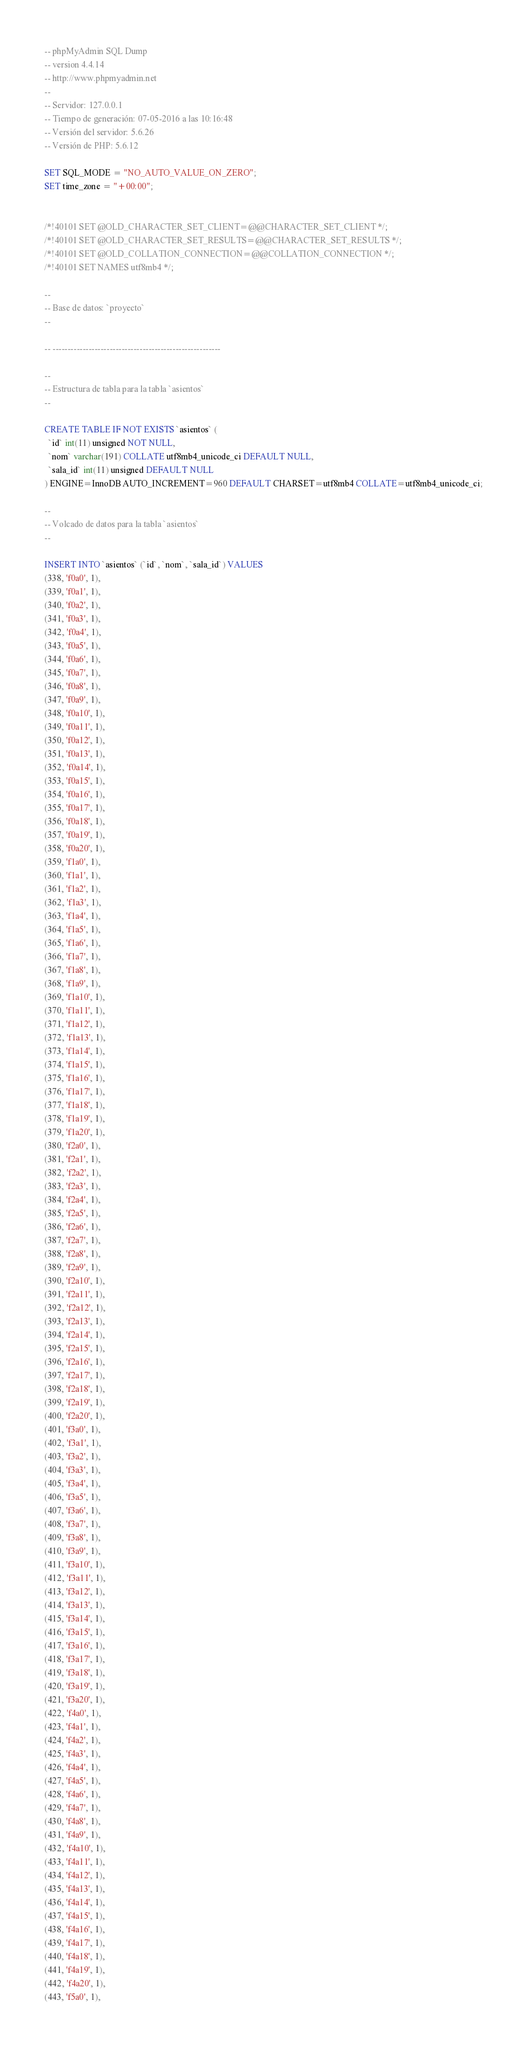Convert code to text. <code><loc_0><loc_0><loc_500><loc_500><_SQL_>-- phpMyAdmin SQL Dump
-- version 4.4.14
-- http://www.phpmyadmin.net
--
-- Servidor: 127.0.0.1
-- Tiempo de generación: 07-05-2016 a las 10:16:48
-- Versión del servidor: 5.6.26
-- Versión de PHP: 5.6.12

SET SQL_MODE = "NO_AUTO_VALUE_ON_ZERO";
SET time_zone = "+00:00";


/*!40101 SET @OLD_CHARACTER_SET_CLIENT=@@CHARACTER_SET_CLIENT */;
/*!40101 SET @OLD_CHARACTER_SET_RESULTS=@@CHARACTER_SET_RESULTS */;
/*!40101 SET @OLD_COLLATION_CONNECTION=@@COLLATION_CONNECTION */;
/*!40101 SET NAMES utf8mb4 */;

--
-- Base de datos: `proyecto`
--

-- --------------------------------------------------------

--
-- Estructura de tabla para la tabla `asientos`
--

CREATE TABLE IF NOT EXISTS `asientos` (
  `id` int(11) unsigned NOT NULL,
  `nom` varchar(191) COLLATE utf8mb4_unicode_ci DEFAULT NULL,
  `sala_id` int(11) unsigned DEFAULT NULL
) ENGINE=InnoDB AUTO_INCREMENT=960 DEFAULT CHARSET=utf8mb4 COLLATE=utf8mb4_unicode_ci;

--
-- Volcado de datos para la tabla `asientos`
--

INSERT INTO `asientos` (`id`, `nom`, `sala_id`) VALUES
(338, 'f0a0', 1),
(339, 'f0a1', 1),
(340, 'f0a2', 1),
(341, 'f0a3', 1),
(342, 'f0a4', 1),
(343, 'f0a5', 1),
(344, 'f0a6', 1),
(345, 'f0a7', 1),
(346, 'f0a8', 1),
(347, 'f0a9', 1),
(348, 'f0a10', 1),
(349, 'f0a11', 1),
(350, 'f0a12', 1),
(351, 'f0a13', 1),
(352, 'f0a14', 1),
(353, 'f0a15', 1),
(354, 'f0a16', 1),
(355, 'f0a17', 1),
(356, 'f0a18', 1),
(357, 'f0a19', 1),
(358, 'f0a20', 1),
(359, 'f1a0', 1),
(360, 'f1a1', 1),
(361, 'f1a2', 1),
(362, 'f1a3', 1),
(363, 'f1a4', 1),
(364, 'f1a5', 1),
(365, 'f1a6', 1),
(366, 'f1a7', 1),
(367, 'f1a8', 1),
(368, 'f1a9', 1),
(369, 'f1a10', 1),
(370, 'f1a11', 1),
(371, 'f1a12', 1),
(372, 'f1a13', 1),
(373, 'f1a14', 1),
(374, 'f1a15', 1),
(375, 'f1a16', 1),
(376, 'f1a17', 1),
(377, 'f1a18', 1),
(378, 'f1a19', 1),
(379, 'f1a20', 1),
(380, 'f2a0', 1),
(381, 'f2a1', 1),
(382, 'f2a2', 1),
(383, 'f2a3', 1),
(384, 'f2a4', 1),
(385, 'f2a5', 1),
(386, 'f2a6', 1),
(387, 'f2a7', 1),
(388, 'f2a8', 1),
(389, 'f2a9', 1),
(390, 'f2a10', 1),
(391, 'f2a11', 1),
(392, 'f2a12', 1),
(393, 'f2a13', 1),
(394, 'f2a14', 1),
(395, 'f2a15', 1),
(396, 'f2a16', 1),
(397, 'f2a17', 1),
(398, 'f2a18', 1),
(399, 'f2a19', 1),
(400, 'f2a20', 1),
(401, 'f3a0', 1),
(402, 'f3a1', 1),
(403, 'f3a2', 1),
(404, 'f3a3', 1),
(405, 'f3a4', 1),
(406, 'f3a5', 1),
(407, 'f3a6', 1),
(408, 'f3a7', 1),
(409, 'f3a8', 1),
(410, 'f3a9', 1),
(411, 'f3a10', 1),
(412, 'f3a11', 1),
(413, 'f3a12', 1),
(414, 'f3a13', 1),
(415, 'f3a14', 1),
(416, 'f3a15', 1),
(417, 'f3a16', 1),
(418, 'f3a17', 1),
(419, 'f3a18', 1),
(420, 'f3a19', 1),
(421, 'f3a20', 1),
(422, 'f4a0', 1),
(423, 'f4a1', 1),
(424, 'f4a2', 1),
(425, 'f4a3', 1),
(426, 'f4a4', 1),
(427, 'f4a5', 1),
(428, 'f4a6', 1),
(429, 'f4a7', 1),
(430, 'f4a8', 1),
(431, 'f4a9', 1),
(432, 'f4a10', 1),
(433, 'f4a11', 1),
(434, 'f4a12', 1),
(435, 'f4a13', 1),
(436, 'f4a14', 1),
(437, 'f4a15', 1),
(438, 'f4a16', 1),
(439, 'f4a17', 1),
(440, 'f4a18', 1),
(441, 'f4a19', 1),
(442, 'f4a20', 1),
(443, 'f5a0', 1),</code> 